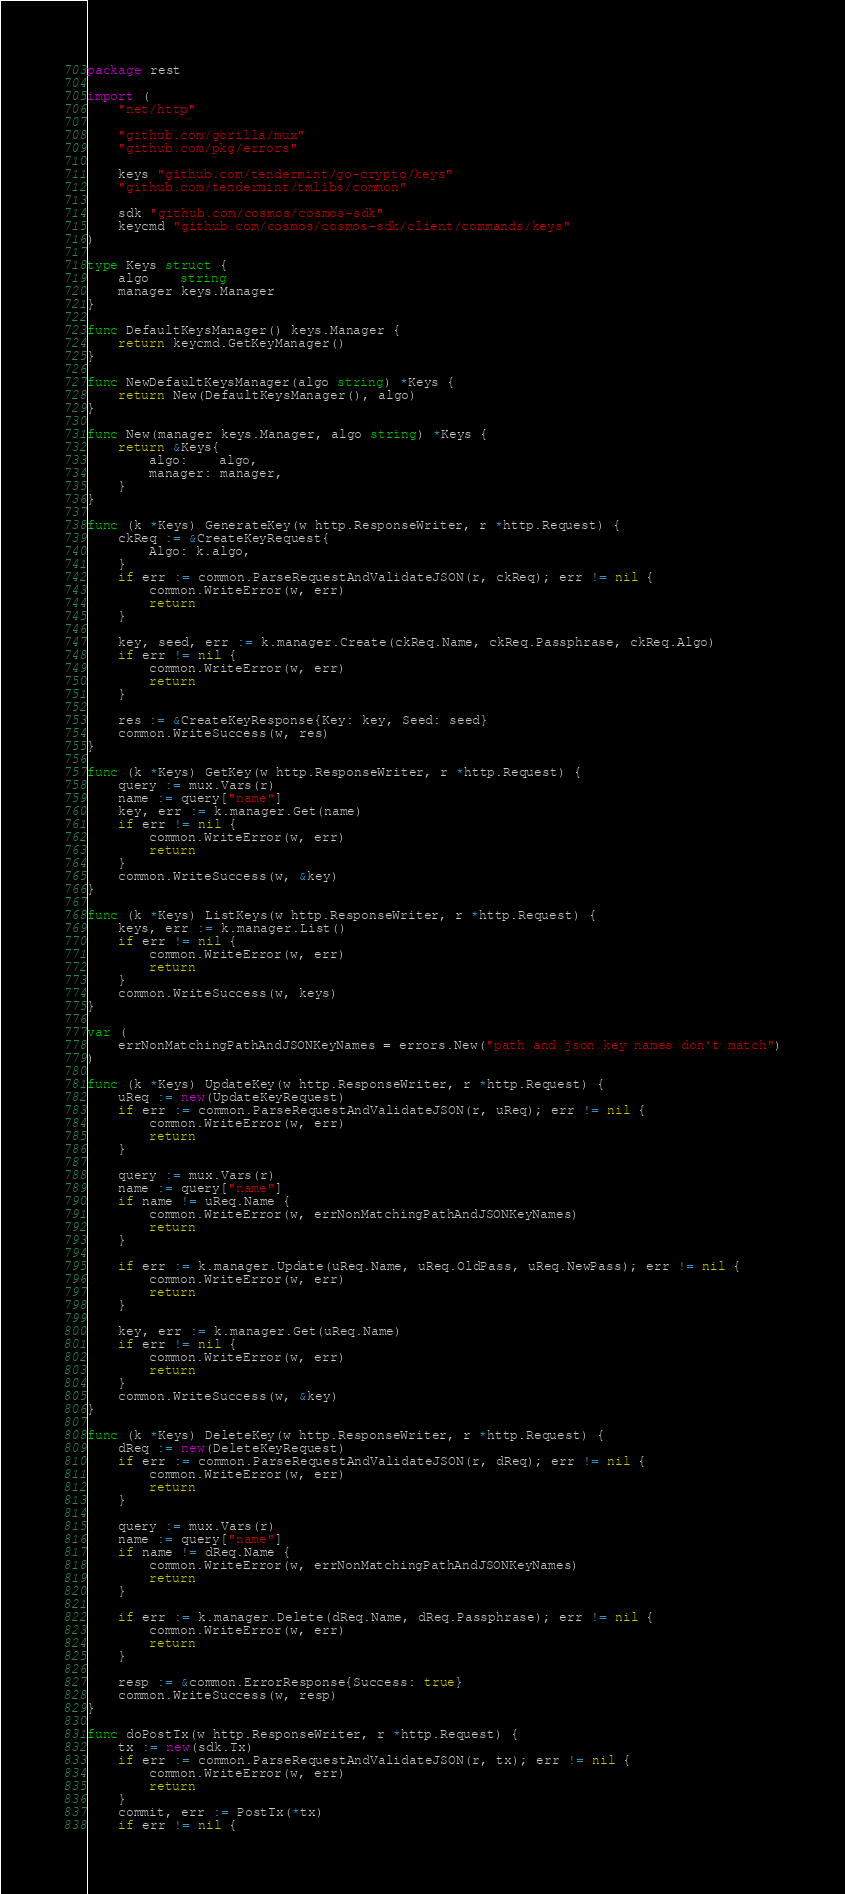Convert code to text. <code><loc_0><loc_0><loc_500><loc_500><_Go_>package rest

import (
	"net/http"

	"github.com/gorilla/mux"
	"github.com/pkg/errors"

	keys "github.com/tendermint/go-crypto/keys"
	"github.com/tendermint/tmlibs/common"

	sdk "github.com/cosmos/cosmos-sdk"
	keycmd "github.com/cosmos/cosmos-sdk/client/commands/keys"
)

type Keys struct {
	algo    string
	manager keys.Manager
}

func DefaultKeysManager() keys.Manager {
	return keycmd.GetKeyManager()
}

func NewDefaultKeysManager(algo string) *Keys {
	return New(DefaultKeysManager(), algo)
}

func New(manager keys.Manager, algo string) *Keys {
	return &Keys{
		algo:    algo,
		manager: manager,
	}
}

func (k *Keys) GenerateKey(w http.ResponseWriter, r *http.Request) {
	ckReq := &CreateKeyRequest{
		Algo: k.algo,
	}
	if err := common.ParseRequestAndValidateJSON(r, ckReq); err != nil {
		common.WriteError(w, err)
		return
	}

	key, seed, err := k.manager.Create(ckReq.Name, ckReq.Passphrase, ckReq.Algo)
	if err != nil {
		common.WriteError(w, err)
		return
	}

	res := &CreateKeyResponse{Key: key, Seed: seed}
	common.WriteSuccess(w, res)
}

func (k *Keys) GetKey(w http.ResponseWriter, r *http.Request) {
	query := mux.Vars(r)
	name := query["name"]
	key, err := k.manager.Get(name)
	if err != nil {
		common.WriteError(w, err)
		return
	}
	common.WriteSuccess(w, &key)
}

func (k *Keys) ListKeys(w http.ResponseWriter, r *http.Request) {
	keys, err := k.manager.List()
	if err != nil {
		common.WriteError(w, err)
		return
	}
	common.WriteSuccess(w, keys)
}

var (
	errNonMatchingPathAndJSONKeyNames = errors.New("path and json key names don't match")
)

func (k *Keys) UpdateKey(w http.ResponseWriter, r *http.Request) {
	uReq := new(UpdateKeyRequest)
	if err := common.ParseRequestAndValidateJSON(r, uReq); err != nil {
		common.WriteError(w, err)
		return
	}

	query := mux.Vars(r)
	name := query["name"]
	if name != uReq.Name {
		common.WriteError(w, errNonMatchingPathAndJSONKeyNames)
		return
	}

	if err := k.manager.Update(uReq.Name, uReq.OldPass, uReq.NewPass); err != nil {
		common.WriteError(w, err)
		return
	}

	key, err := k.manager.Get(uReq.Name)
	if err != nil {
		common.WriteError(w, err)
		return
	}
	common.WriteSuccess(w, &key)
}

func (k *Keys) DeleteKey(w http.ResponseWriter, r *http.Request) {
	dReq := new(DeleteKeyRequest)
	if err := common.ParseRequestAndValidateJSON(r, dReq); err != nil {
		common.WriteError(w, err)
		return
	}

	query := mux.Vars(r)
	name := query["name"]
	if name != dReq.Name {
		common.WriteError(w, errNonMatchingPathAndJSONKeyNames)
		return
	}

	if err := k.manager.Delete(dReq.Name, dReq.Passphrase); err != nil {
		common.WriteError(w, err)
		return
	}

	resp := &common.ErrorResponse{Success: true}
	common.WriteSuccess(w, resp)
}

func doPostTx(w http.ResponseWriter, r *http.Request) {
	tx := new(sdk.Tx)
	if err := common.ParseRequestAndValidateJSON(r, tx); err != nil {
		common.WriteError(w, err)
		return
	}
	commit, err := PostTx(*tx)
	if err != nil {</code> 